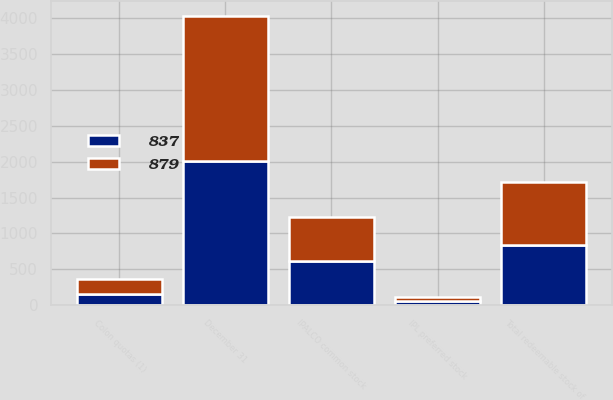<chart> <loc_0><loc_0><loc_500><loc_500><stacked_bar_chart><ecel><fcel>December 31<fcel>IPALCO common stock<fcel>Colon quotas (1)<fcel>IPL preferred stock<fcel>Total redeemable stock of<nl><fcel>879<fcel>2018<fcel>618<fcel>201<fcel>60<fcel>879<nl><fcel>837<fcel>2017<fcel>618<fcel>159<fcel>60<fcel>837<nl></chart> 